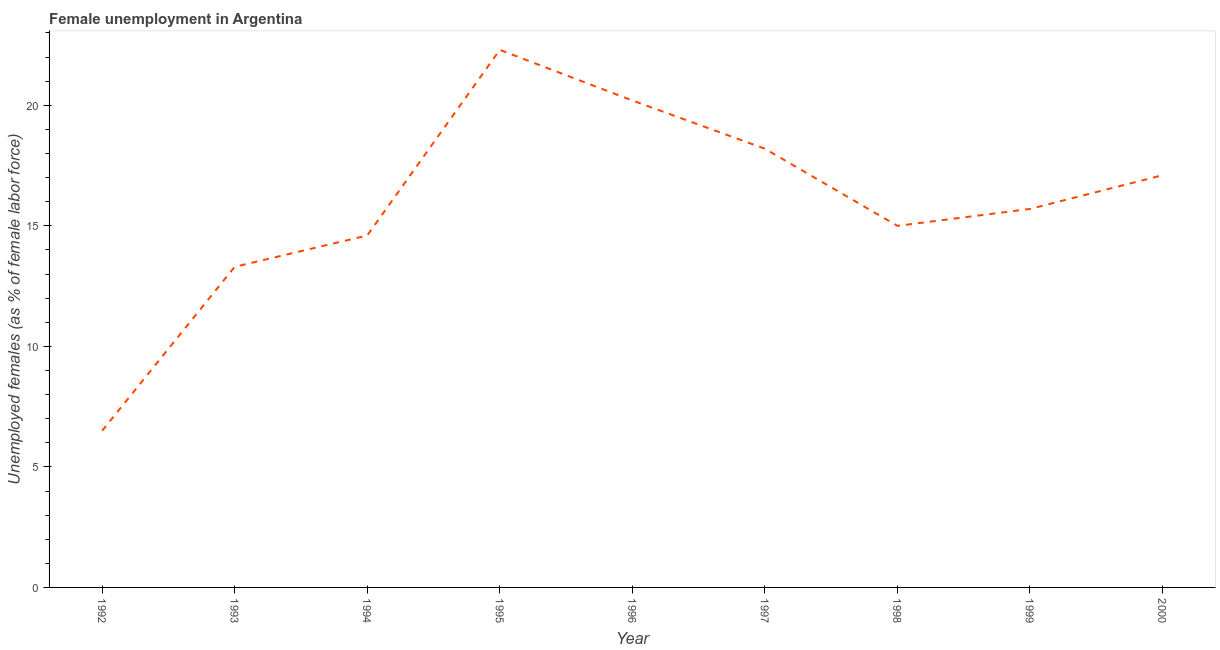What is the unemployed females population in 1996?
Your answer should be compact. 20.2. Across all years, what is the maximum unemployed females population?
Give a very brief answer. 22.3. Across all years, what is the minimum unemployed females population?
Your response must be concise. 6.5. In which year was the unemployed females population minimum?
Provide a short and direct response. 1992. What is the sum of the unemployed females population?
Your answer should be very brief. 142.9. What is the difference between the unemployed females population in 1993 and 1998?
Give a very brief answer. -1.7. What is the average unemployed females population per year?
Provide a short and direct response. 15.88. What is the median unemployed females population?
Offer a very short reply. 15.7. In how many years, is the unemployed females population greater than 12 %?
Offer a very short reply. 8. Do a majority of the years between 1996 and 1993 (inclusive) have unemployed females population greater than 18 %?
Provide a succinct answer. Yes. What is the ratio of the unemployed females population in 1994 to that in 1997?
Your answer should be very brief. 0.8. Is the difference between the unemployed females population in 1994 and 1997 greater than the difference between any two years?
Provide a succinct answer. No. What is the difference between the highest and the second highest unemployed females population?
Offer a very short reply. 2.1. What is the difference between the highest and the lowest unemployed females population?
Give a very brief answer. 15.8. Does the unemployed females population monotonically increase over the years?
Your response must be concise. No. How many lines are there?
Keep it short and to the point. 1. Does the graph contain any zero values?
Ensure brevity in your answer.  No. Does the graph contain grids?
Offer a terse response. No. What is the title of the graph?
Provide a succinct answer. Female unemployment in Argentina. What is the label or title of the Y-axis?
Make the answer very short. Unemployed females (as % of female labor force). What is the Unemployed females (as % of female labor force) in 1992?
Ensure brevity in your answer.  6.5. What is the Unemployed females (as % of female labor force) of 1993?
Keep it short and to the point. 13.3. What is the Unemployed females (as % of female labor force) of 1994?
Your answer should be compact. 14.6. What is the Unemployed females (as % of female labor force) in 1995?
Keep it short and to the point. 22.3. What is the Unemployed females (as % of female labor force) of 1996?
Provide a succinct answer. 20.2. What is the Unemployed females (as % of female labor force) of 1997?
Your answer should be compact. 18.2. What is the Unemployed females (as % of female labor force) in 1999?
Give a very brief answer. 15.7. What is the Unemployed females (as % of female labor force) in 2000?
Offer a terse response. 17.1. What is the difference between the Unemployed females (as % of female labor force) in 1992 and 1994?
Offer a terse response. -8.1. What is the difference between the Unemployed females (as % of female labor force) in 1992 and 1995?
Your response must be concise. -15.8. What is the difference between the Unemployed females (as % of female labor force) in 1992 and 1996?
Provide a short and direct response. -13.7. What is the difference between the Unemployed females (as % of female labor force) in 1993 and 1996?
Provide a short and direct response. -6.9. What is the difference between the Unemployed females (as % of female labor force) in 1993 and 1999?
Offer a very short reply. -2.4. What is the difference between the Unemployed females (as % of female labor force) in 1993 and 2000?
Make the answer very short. -3.8. What is the difference between the Unemployed females (as % of female labor force) in 1994 and 1995?
Your answer should be compact. -7.7. What is the difference between the Unemployed females (as % of female labor force) in 1994 and 1998?
Offer a terse response. -0.4. What is the difference between the Unemployed females (as % of female labor force) in 1994 and 1999?
Offer a very short reply. -1.1. What is the difference between the Unemployed females (as % of female labor force) in 1994 and 2000?
Ensure brevity in your answer.  -2.5. What is the difference between the Unemployed females (as % of female labor force) in 1996 and 1998?
Provide a short and direct response. 5.2. What is the difference between the Unemployed females (as % of female labor force) in 1996 and 2000?
Offer a very short reply. 3.1. What is the difference between the Unemployed females (as % of female labor force) in 1997 and 1999?
Offer a terse response. 2.5. What is the ratio of the Unemployed females (as % of female labor force) in 1992 to that in 1993?
Provide a succinct answer. 0.49. What is the ratio of the Unemployed females (as % of female labor force) in 1992 to that in 1994?
Your answer should be compact. 0.45. What is the ratio of the Unemployed females (as % of female labor force) in 1992 to that in 1995?
Offer a very short reply. 0.29. What is the ratio of the Unemployed females (as % of female labor force) in 1992 to that in 1996?
Your response must be concise. 0.32. What is the ratio of the Unemployed females (as % of female labor force) in 1992 to that in 1997?
Ensure brevity in your answer.  0.36. What is the ratio of the Unemployed females (as % of female labor force) in 1992 to that in 1998?
Your answer should be compact. 0.43. What is the ratio of the Unemployed females (as % of female labor force) in 1992 to that in 1999?
Give a very brief answer. 0.41. What is the ratio of the Unemployed females (as % of female labor force) in 1992 to that in 2000?
Make the answer very short. 0.38. What is the ratio of the Unemployed females (as % of female labor force) in 1993 to that in 1994?
Offer a terse response. 0.91. What is the ratio of the Unemployed females (as % of female labor force) in 1993 to that in 1995?
Keep it short and to the point. 0.6. What is the ratio of the Unemployed females (as % of female labor force) in 1993 to that in 1996?
Provide a short and direct response. 0.66. What is the ratio of the Unemployed females (as % of female labor force) in 1993 to that in 1997?
Offer a very short reply. 0.73. What is the ratio of the Unemployed females (as % of female labor force) in 1993 to that in 1998?
Offer a very short reply. 0.89. What is the ratio of the Unemployed females (as % of female labor force) in 1993 to that in 1999?
Give a very brief answer. 0.85. What is the ratio of the Unemployed females (as % of female labor force) in 1993 to that in 2000?
Ensure brevity in your answer.  0.78. What is the ratio of the Unemployed females (as % of female labor force) in 1994 to that in 1995?
Offer a very short reply. 0.66. What is the ratio of the Unemployed females (as % of female labor force) in 1994 to that in 1996?
Your answer should be very brief. 0.72. What is the ratio of the Unemployed females (as % of female labor force) in 1994 to that in 1997?
Your answer should be very brief. 0.8. What is the ratio of the Unemployed females (as % of female labor force) in 1994 to that in 1998?
Offer a very short reply. 0.97. What is the ratio of the Unemployed females (as % of female labor force) in 1994 to that in 1999?
Give a very brief answer. 0.93. What is the ratio of the Unemployed females (as % of female labor force) in 1994 to that in 2000?
Offer a terse response. 0.85. What is the ratio of the Unemployed females (as % of female labor force) in 1995 to that in 1996?
Provide a short and direct response. 1.1. What is the ratio of the Unemployed females (as % of female labor force) in 1995 to that in 1997?
Give a very brief answer. 1.23. What is the ratio of the Unemployed females (as % of female labor force) in 1995 to that in 1998?
Offer a very short reply. 1.49. What is the ratio of the Unemployed females (as % of female labor force) in 1995 to that in 1999?
Provide a succinct answer. 1.42. What is the ratio of the Unemployed females (as % of female labor force) in 1995 to that in 2000?
Give a very brief answer. 1.3. What is the ratio of the Unemployed females (as % of female labor force) in 1996 to that in 1997?
Offer a very short reply. 1.11. What is the ratio of the Unemployed females (as % of female labor force) in 1996 to that in 1998?
Ensure brevity in your answer.  1.35. What is the ratio of the Unemployed females (as % of female labor force) in 1996 to that in 1999?
Provide a succinct answer. 1.29. What is the ratio of the Unemployed females (as % of female labor force) in 1996 to that in 2000?
Offer a terse response. 1.18. What is the ratio of the Unemployed females (as % of female labor force) in 1997 to that in 1998?
Your answer should be very brief. 1.21. What is the ratio of the Unemployed females (as % of female labor force) in 1997 to that in 1999?
Provide a succinct answer. 1.16. What is the ratio of the Unemployed females (as % of female labor force) in 1997 to that in 2000?
Make the answer very short. 1.06. What is the ratio of the Unemployed females (as % of female labor force) in 1998 to that in 1999?
Your answer should be very brief. 0.95. What is the ratio of the Unemployed females (as % of female labor force) in 1998 to that in 2000?
Offer a terse response. 0.88. What is the ratio of the Unemployed females (as % of female labor force) in 1999 to that in 2000?
Provide a succinct answer. 0.92. 